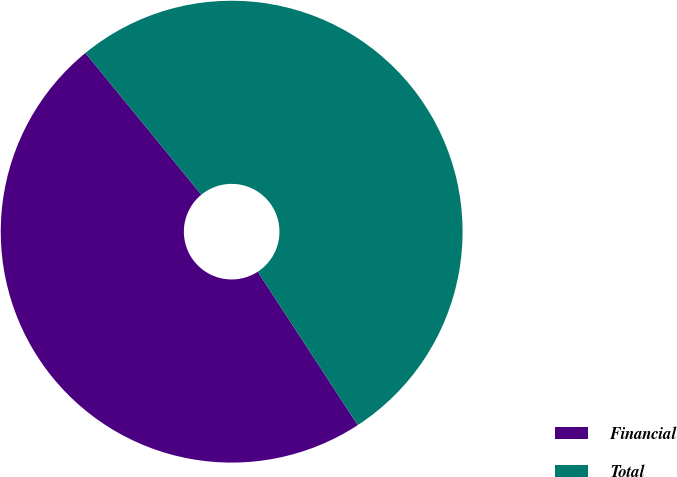Convert chart. <chart><loc_0><loc_0><loc_500><loc_500><pie_chart><fcel>Financial<fcel>Total<nl><fcel>48.28%<fcel>51.72%<nl></chart> 